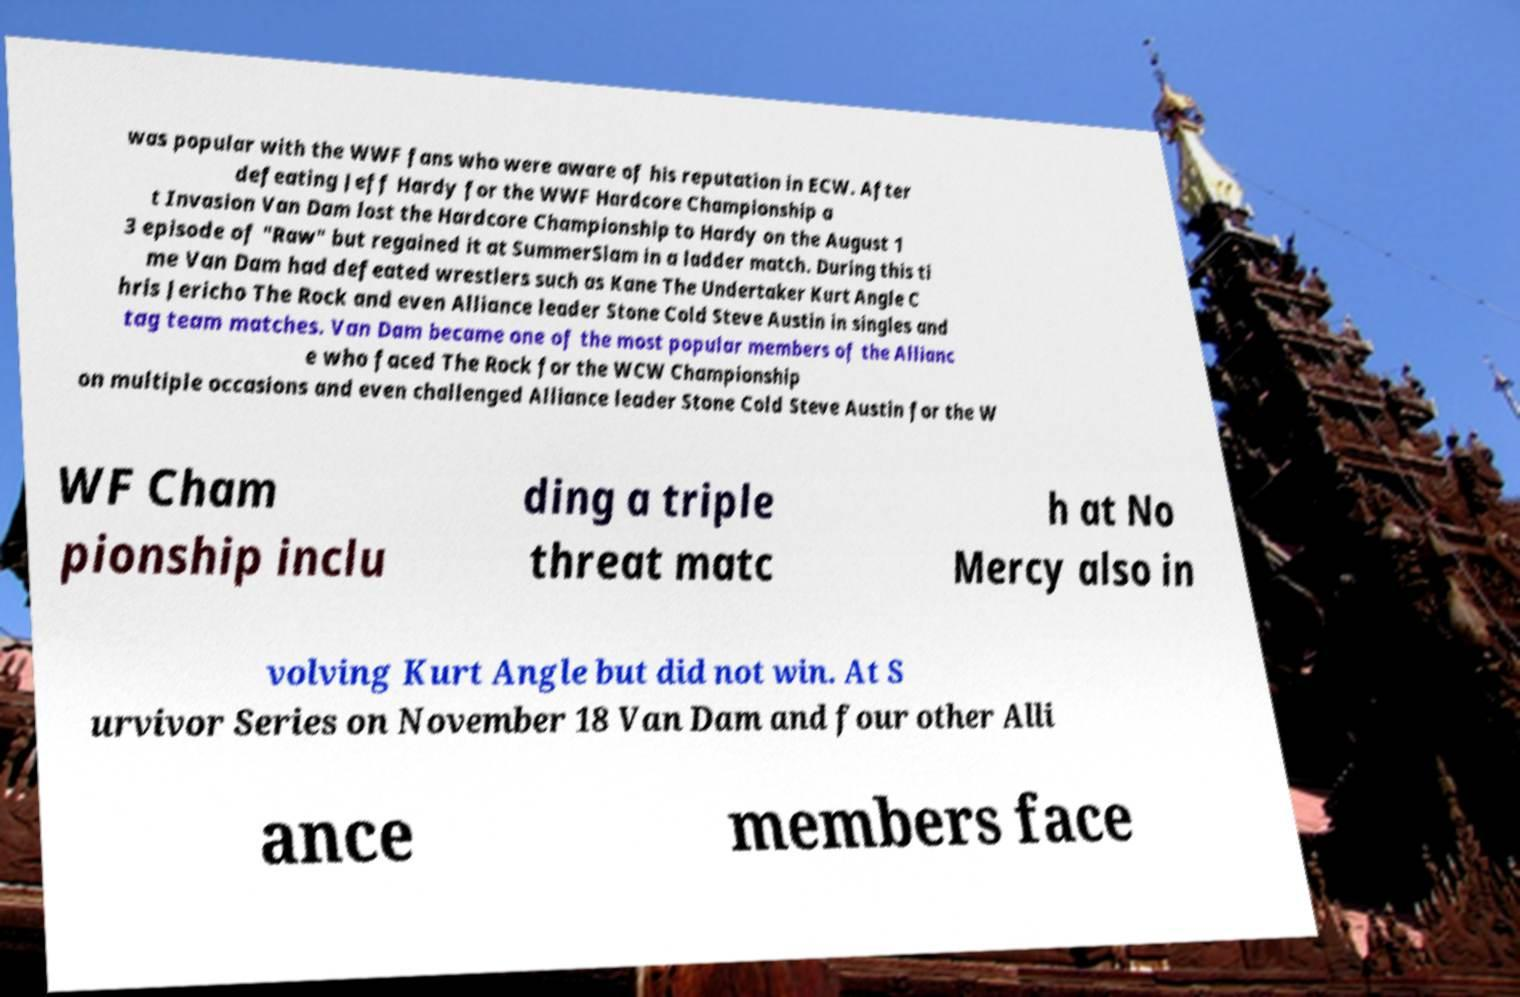I need the written content from this picture converted into text. Can you do that? was popular with the WWF fans who were aware of his reputation in ECW. After defeating Jeff Hardy for the WWF Hardcore Championship a t Invasion Van Dam lost the Hardcore Championship to Hardy on the August 1 3 episode of "Raw" but regained it at SummerSlam in a ladder match. During this ti me Van Dam had defeated wrestlers such as Kane The Undertaker Kurt Angle C hris Jericho The Rock and even Alliance leader Stone Cold Steve Austin in singles and tag team matches. Van Dam became one of the most popular members of the Allianc e who faced The Rock for the WCW Championship on multiple occasions and even challenged Alliance leader Stone Cold Steve Austin for the W WF Cham pionship inclu ding a triple threat matc h at No Mercy also in volving Kurt Angle but did not win. At S urvivor Series on November 18 Van Dam and four other Alli ance members face 